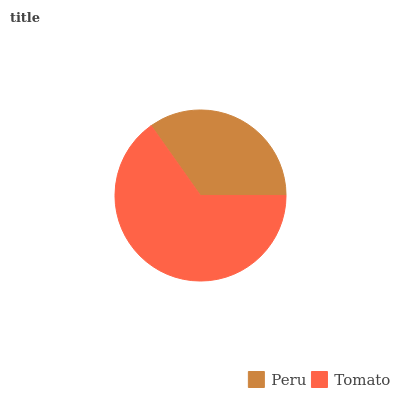Is Peru the minimum?
Answer yes or no. Yes. Is Tomato the maximum?
Answer yes or no. Yes. Is Tomato the minimum?
Answer yes or no. No. Is Tomato greater than Peru?
Answer yes or no. Yes. Is Peru less than Tomato?
Answer yes or no. Yes. Is Peru greater than Tomato?
Answer yes or no. No. Is Tomato less than Peru?
Answer yes or no. No. Is Tomato the high median?
Answer yes or no. Yes. Is Peru the low median?
Answer yes or no. Yes. Is Peru the high median?
Answer yes or no. No. Is Tomato the low median?
Answer yes or no. No. 